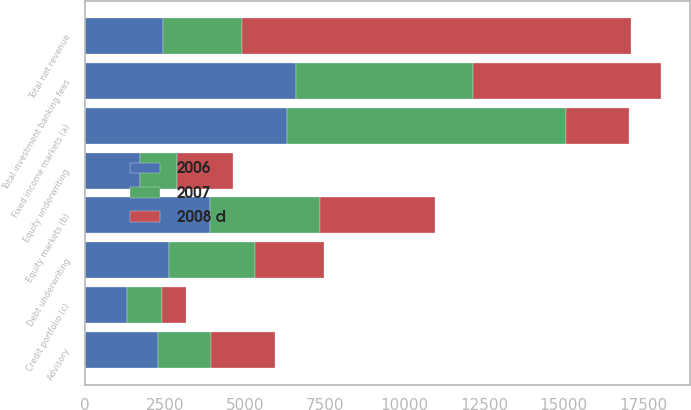Convert chart to OTSL. <chart><loc_0><loc_0><loc_500><loc_500><stacked_bar_chart><ecel><fcel>Advisory<fcel>Equity underwriting<fcel>Debt underwriting<fcel>Total investment banking fees<fcel>Fixed income markets (a)<fcel>Equity markets (b)<fcel>Credit portfolio (c)<fcel>Total net revenue<nl><fcel>2008 d<fcel>2008<fcel>1749<fcel>2150<fcel>5907<fcel>1957<fcel>3611<fcel>739<fcel>12214<nl><fcel>2006<fcel>2273<fcel>1713<fcel>2630<fcel>6616<fcel>6339<fcel>3903<fcel>1312<fcel>2451.5<nl><fcel>2007<fcel>1659<fcel>1178<fcel>2700<fcel>5537<fcel>8736<fcel>3458<fcel>1102<fcel>2451.5<nl></chart> 